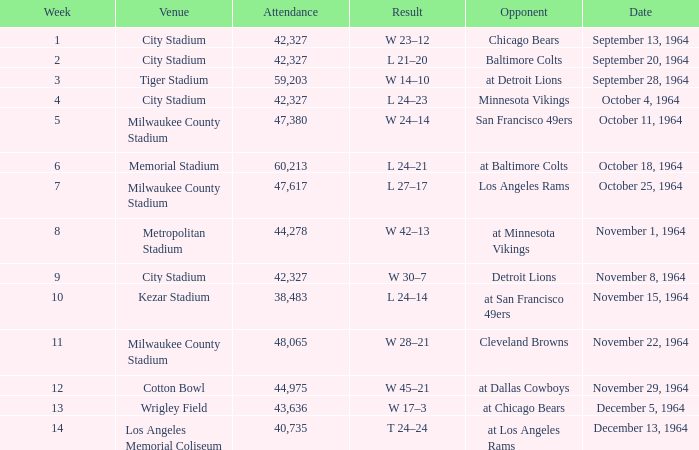What is the average attendance at a week 4 game? 42327.0. 